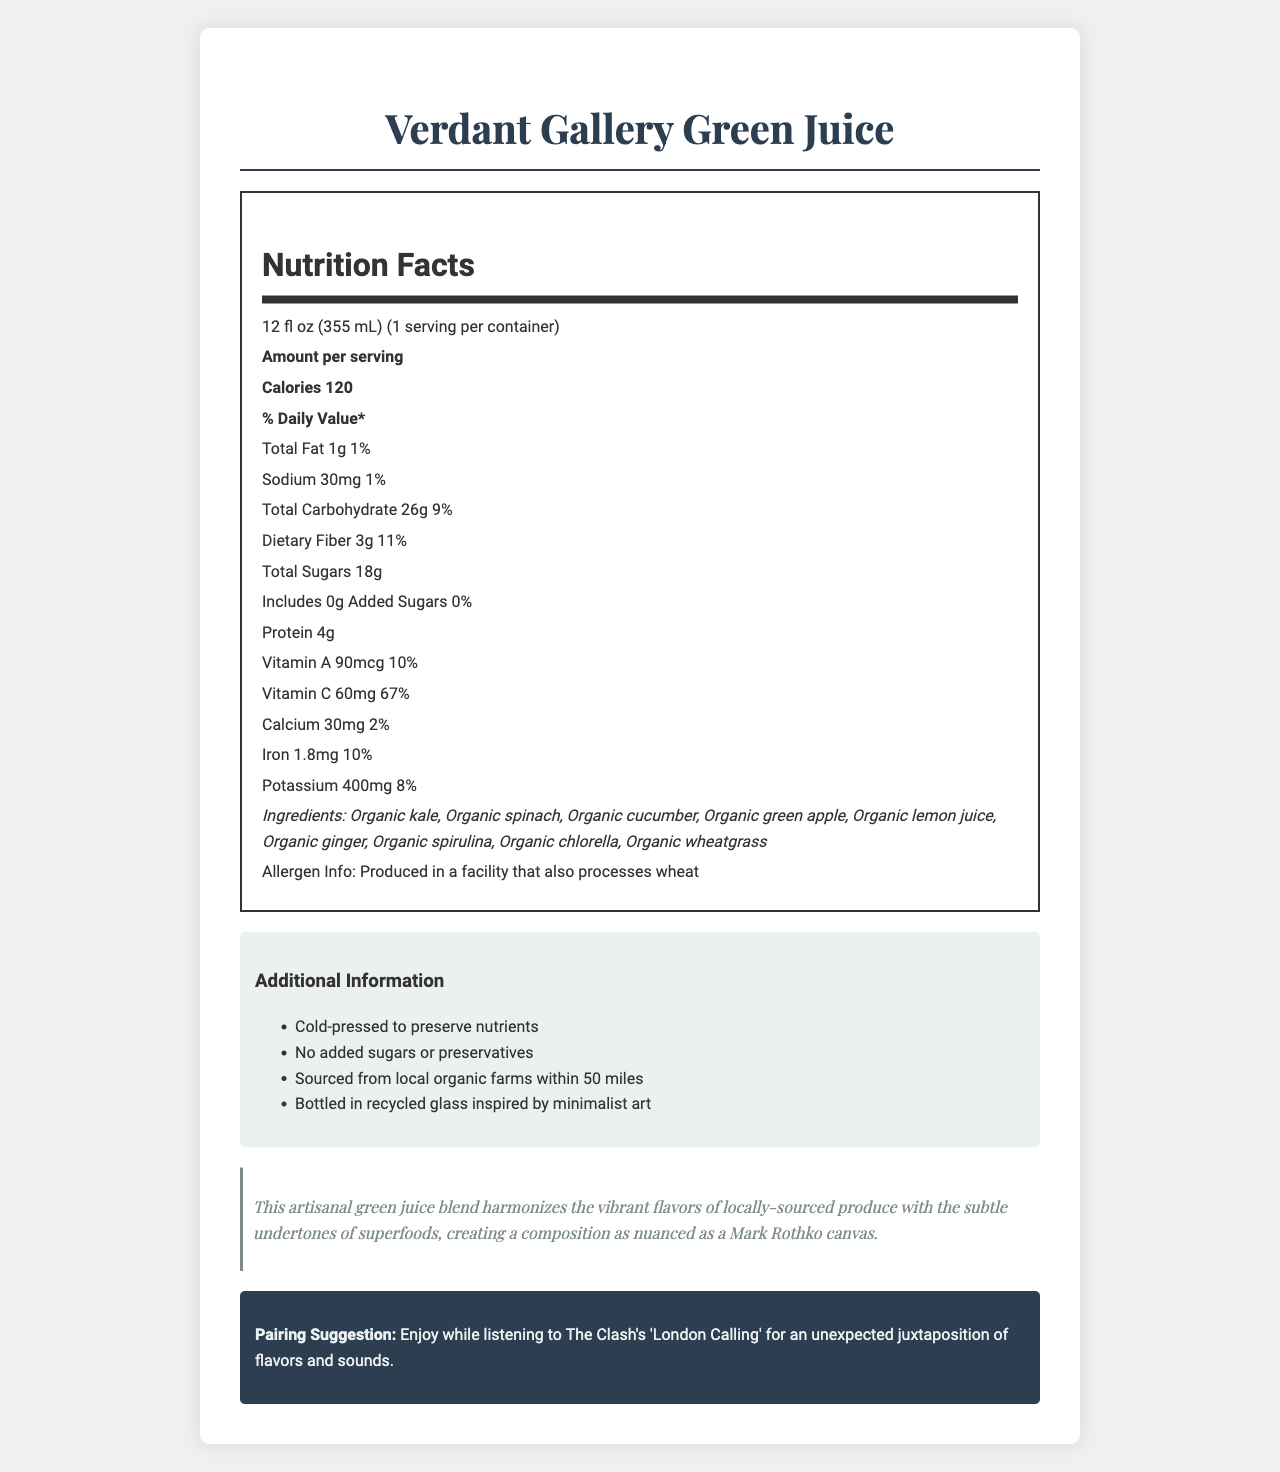what is the serving size of the Verdant Gallery Green Juice? The serving size is explicitly stated in the document as "12 fl oz (355 mL)".
Answer: 12 fl oz (355 mL) How many calories are in one serving of the Verdant Gallery Green Juice? The document states that there are 120 calories per serving.
Answer: 120 What is the protein content of the Verdant Gallery Green Juice? The document specifies that the juice contains 4 grams of protein per serving.
Answer: 4g Can you list the superfood ingredients included in the Verdant Gallery Green Juice? The document lists these ingredients specifically under the "ingredients" section.
Answer: Organic kale, Organic spinach, Organic cucumber, Organic green apple, Organic lemon juice, Organic ginger, Organic spirulina, Organic chlorella, Organic wheatgrass What percentage of the daily value for Vitamin C does the Verdant Gallery Green Juice provide? The document specifies that the juice provides 60mg of Vitamin C, which is 67% of the daily value.
Answer: 67% How much total carbohydrate is in one serving of the Verdant Gallery Green Juice? The document states that the total carbohydrate content is 26 grams per serving.
Answer: 26g How much dietary fiber is in the Verdant Gallery Green Juice? The dietary fiber content is explicitly stated as 3 grams per serving in the document.
Answer: 3g Is the Verdant Gallery Green Juice produced with any added sugars? The document specifies that there are no added sugars (0g) in the juice.
Answer: No What is the allergen information associated with Verdant Gallery Green Juice? The allergen information is provided in the document under the allergen info section.
Answer: Produced in a facility that also processes wheat What is the sodium content in one serving of Verdant Gallery Green Juice? The document states that the sodium content is 30mg per serving.
Answer: 30mg Which of the following statements is true about the Verdant Gallery Green Juice's bottle? A. It is made from plastic. B. It is made from recycled glass inspired by minimalist art. C. It is made from aluminum. The document mentions that the juice is bottled in recycled glass inspired by minimalist art.
Answer: B Which ingredient is not listed in the Verdant Gallery Green Juice? I. Organic kale II. Organic blueberry III. Organic wheatgrass The document lists Organic kale and Organic wheatgrass, but not Organic blueberry.
Answer: II Does the Verdant Gallery Green Juice contain preservatives? (Yes/No) The document specifically mentions that there are no added sugars or preservatives.
Answer: No Summarize the main idea of the Verdant Gallery Green Juice Nutrition Facts label. This summary encapsulates the key nutritional details, ingredients, and additional information about the juice.
Answer: The Verdant Gallery Green Juice is a cold-pressed juice made from locally-sourced superfood ingredients. It contains 120 calories per 12 fl oz serving and provides a range of vitamins, including 67% of daily Vitamin C value. The juice includes Organic kale, spinach, cucumber, and other nutritious ingredients, and is free from added sugars and preservatives, with allergen information indicating it is produced in a facility that processes wheat. The juice is presented in recycled glass bottles inspired by minimalist art. What company's facility produces the Verdant Gallery Green Juice? The document does not specify the company or facility that produces the juice, only that it is produced in a facility that processes wheat.
Answer: Not enough information 